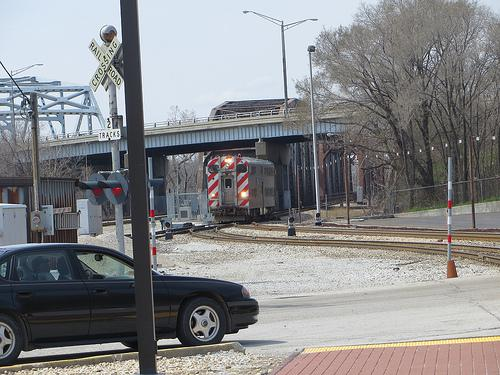Question: where was the photo taken?
Choices:
A. Train tracks.
B. Railroad Crossing.
C. Train station.
D. Subway platform.
Answer with the letter. Answer: B Question: what color is the sky?
Choices:
A. Blue.
B. White.
C. Black.
D. Gray.
Answer with the letter. Answer: D Question: what color is the pavement?
Choices:
A. Dark Grey.
B. Black.
C. Brown.
D. Light Gray.
Answer with the letter. Answer: D Question: what was the weather like?
Choices:
A. Cloudy.
B. Rainy.
C. Snowy.
D. Sunny.
Answer with the letter. Answer: D 